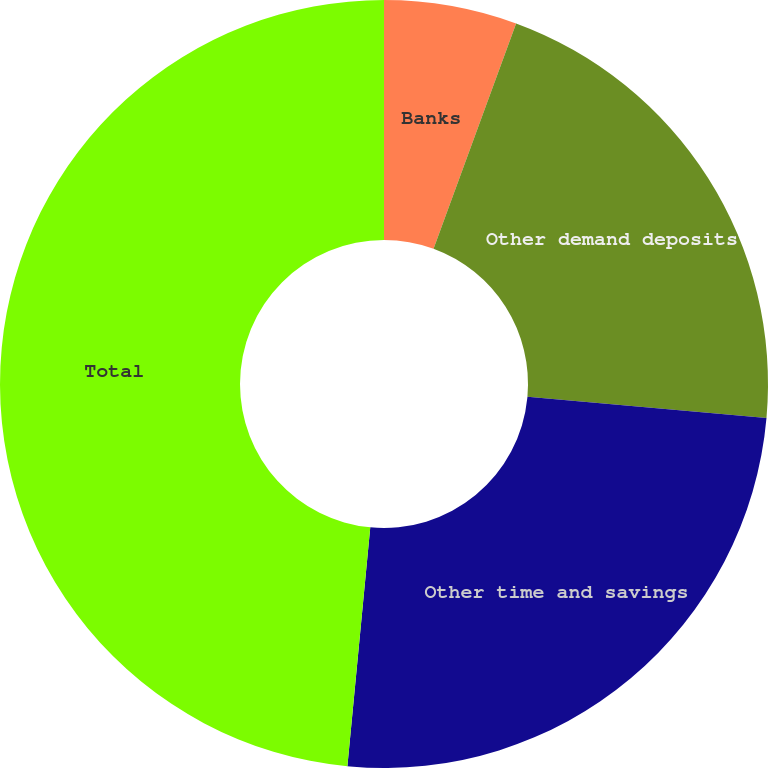Convert chart to OTSL. <chart><loc_0><loc_0><loc_500><loc_500><pie_chart><fcel>Banks<fcel>Other demand deposits<fcel>Other time and savings<fcel>Total<nl><fcel>5.59%<fcel>20.82%<fcel>25.11%<fcel>48.48%<nl></chart> 